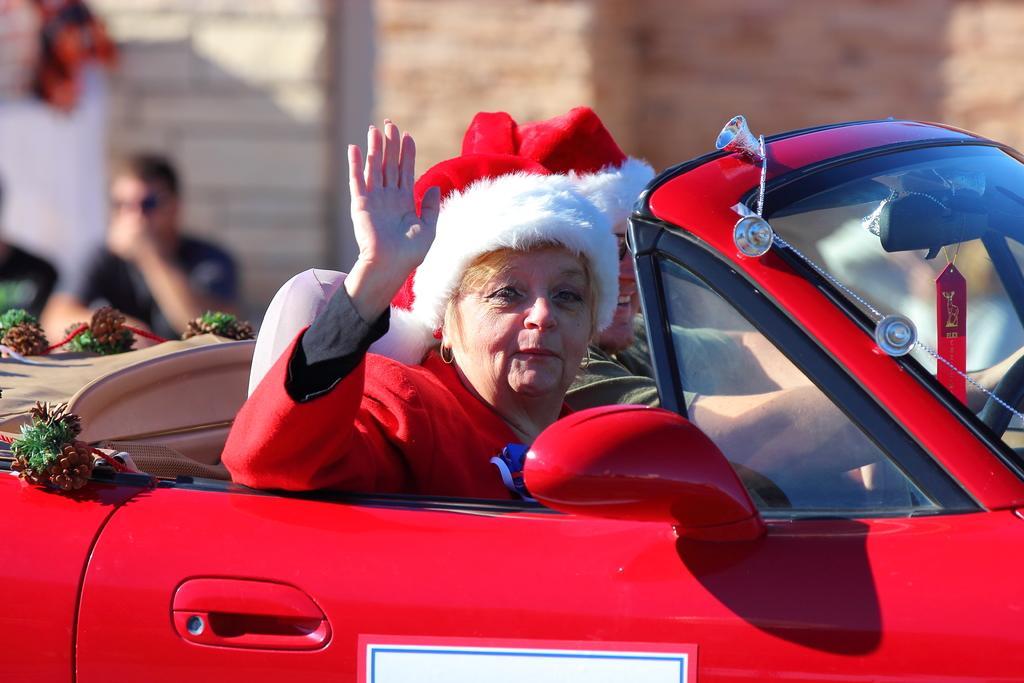Could you give a brief overview of what you see in this image? As we can see in the image there is a red color car. In car there are two people sitting. The women who is sitting over here is wearing red color hat and red color dress. On the left side there is a man wearing black color t shirt and he is sitting over here and the background is little blur. 